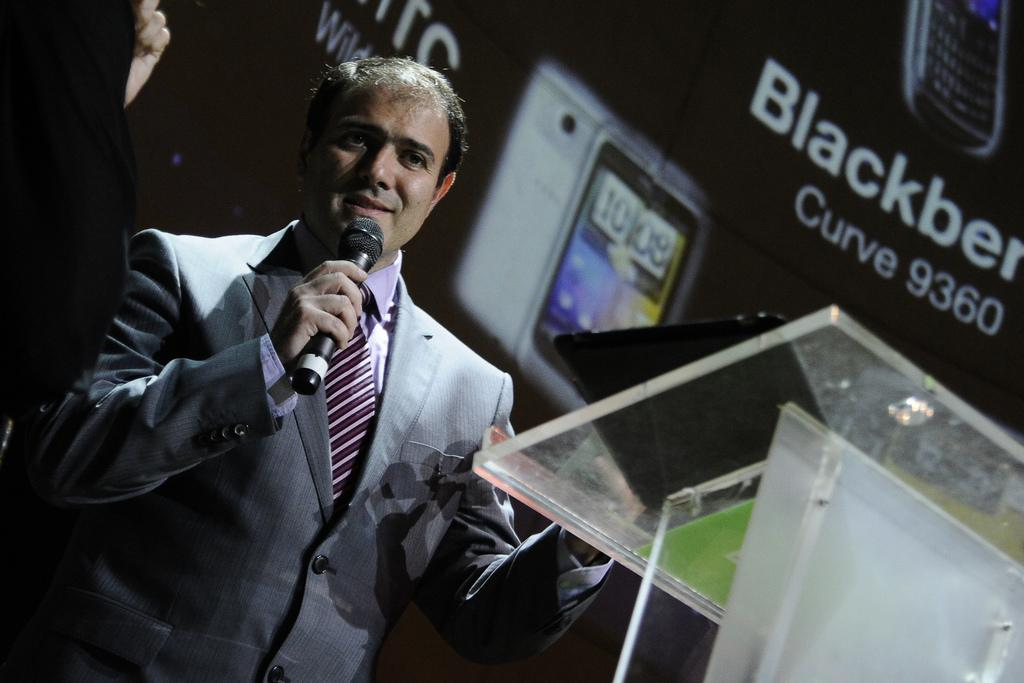What is the man in the image doing? The man is talking on a microphone in the image. What is the man wearing? The man is wearing a suit in the image. What is present in the image besides the man? There is a table, a banner in the background, and a mobile in the image. What type of faucet can be seen in the image? There is no faucet present in the image. How does the man use the knife during his speech? There is no knife present in the image. 